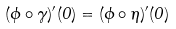<formula> <loc_0><loc_0><loc_500><loc_500>( \phi \circ \gamma ) ^ { \prime } ( 0 ) = ( \phi \circ \eta ) ^ { \prime } ( 0 )</formula> 